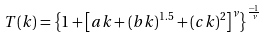Convert formula to latex. <formula><loc_0><loc_0><loc_500><loc_500>T ( k ) = \left \{ 1 + \left [ a k + ( b k ) ^ { 1 . 5 } + ( c k ) ^ { 2 } \right ] ^ { \nu } \right \} ^ { \frac { - 1 } { \nu } }</formula> 